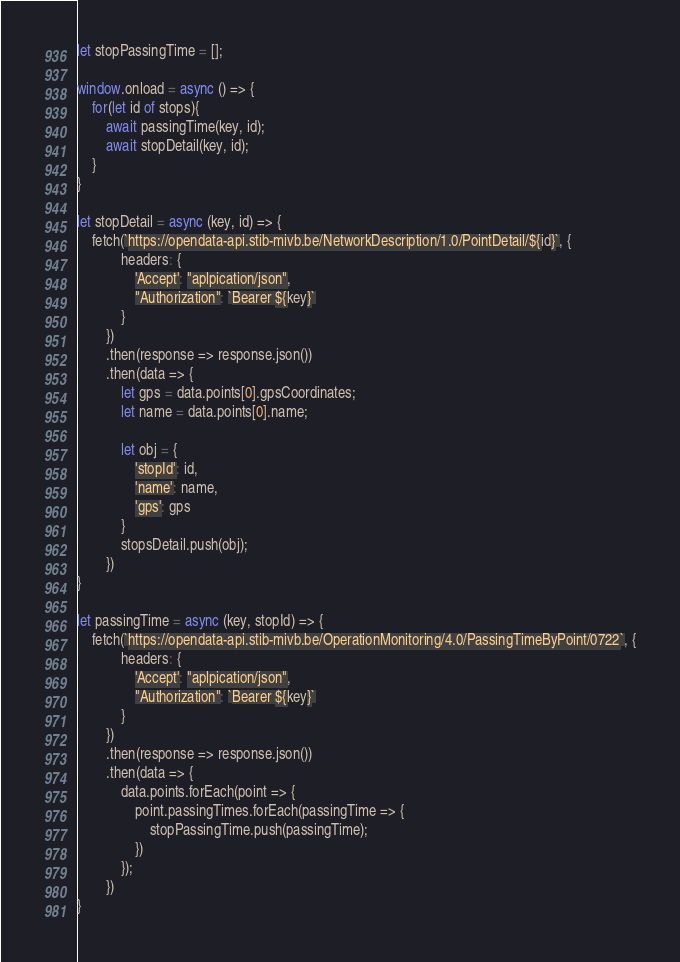<code> <loc_0><loc_0><loc_500><loc_500><_JavaScript_>let stopPassingTime = [];

window.onload = async () => {
    for(let id of stops){
        await passingTime(key, id);
        await stopDetail(key, id);
    }
}

let stopDetail = async (key, id) => {
    fetch(`https://opendata-api.stib-mivb.be/NetworkDescription/1.0/PointDetail/${id}`, {
            headers: {
                'Accept': "aplpication/json",
                "Authorization": `Bearer ${key}`
            }
        })
        .then(response => response.json())
        .then(data => {
            let gps = data.points[0].gpsCoordinates;
            let name = data.points[0].name;

            let obj = {
                'stopId': id,
                'name': name,
                'gps': gps
            }
            stopsDetail.push(obj);
        })
}

let passingTime = async (key, stopId) => {
    fetch(`https://opendata-api.stib-mivb.be/OperationMonitoring/4.0/PassingTimeByPoint/0722`, {
            headers: {
                'Accept': "aplpication/json",
                "Authorization": `Bearer ${key}`
            }
        })
        .then(response => response.json())
        .then(data => {
            data.points.forEach(point => {
                point.passingTimes.forEach(passingTime => {
                    stopPassingTime.push(passingTime);
                })
            });
        })
}</code> 